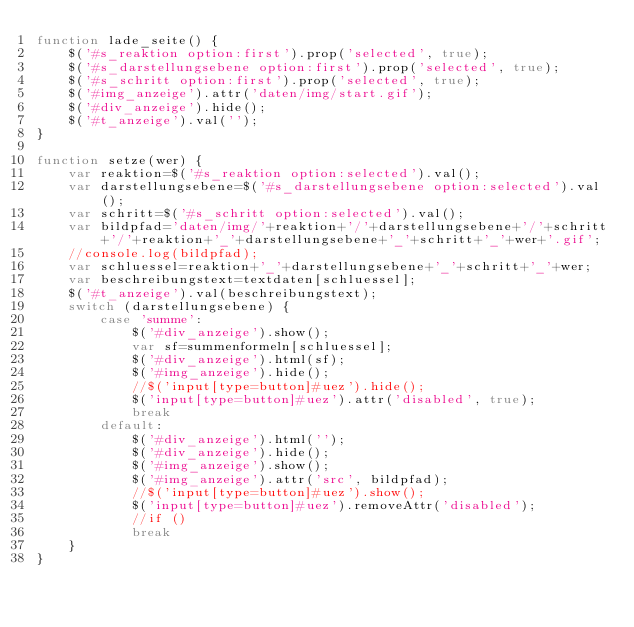<code> <loc_0><loc_0><loc_500><loc_500><_JavaScript_>function lade_seite() {
    $('#s_reaktion option:first').prop('selected', true);
    $('#s_darstellungsebene option:first').prop('selected', true);
    $('#s_schritt option:first').prop('selected', true);
    $('#img_anzeige').attr('daten/img/start.gif');
    $('#div_anzeige').hide();
    $('#t_anzeige').val('');
}

function setze(wer) {
    var reaktion=$('#s_reaktion option:selected').val();
    var darstellungsebene=$('#s_darstellungsebene option:selected').val();
    var schritt=$('#s_schritt option:selected').val();
    var bildpfad='daten/img/'+reaktion+'/'+darstellungsebene+'/'+schritt+'/'+reaktion+'_'+darstellungsebene+'_'+schritt+'_'+wer+'.gif';
    //console.log(bildpfad);
    var schluessel=reaktion+'_'+darstellungsebene+'_'+schritt+'_'+wer;
    var beschreibungstext=textdaten[schluessel];
    $('#t_anzeige').val(beschreibungstext);
    switch (darstellungsebene) {
        case 'summe':
            $('#div_anzeige').show();
            var sf=summenformeln[schluessel];
            $('#div_anzeige').html(sf);
            $('#img_anzeige').hide();
            //$('input[type=button]#uez').hide();
            $('input[type=button]#uez').attr('disabled', true);
            break
        default:
            $('#div_anzeige').html('');
            $('#div_anzeige').hide();
            $('#img_anzeige').show();
            $('#img_anzeige').attr('src', bildpfad);
            //$('input[type=button]#uez').show();
            $('input[type=button]#uez').removeAttr('disabled');
            //if ()
            break
    } 
}
</code> 